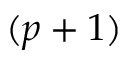<formula> <loc_0><loc_0><loc_500><loc_500>( p + 1 )</formula> 